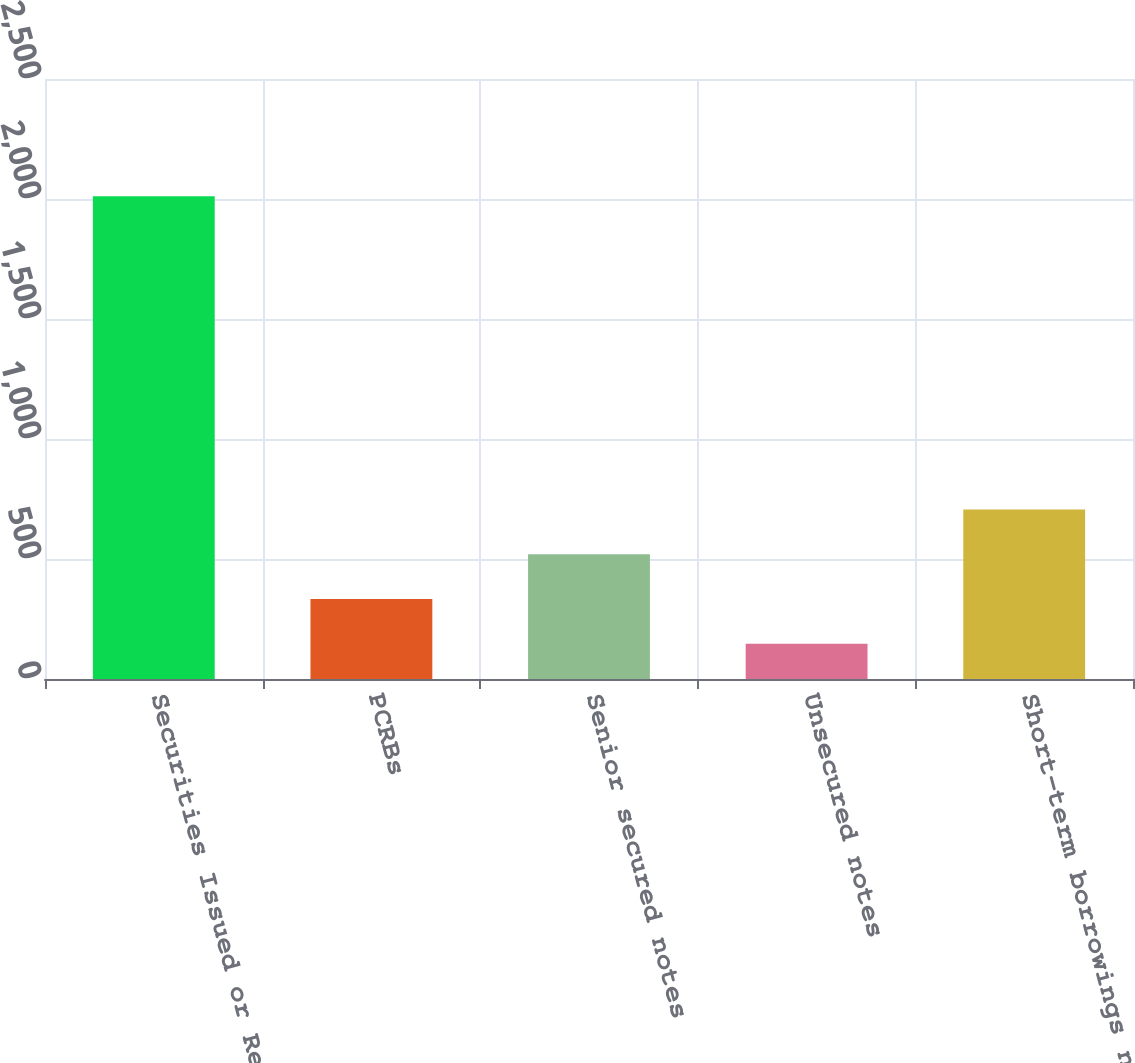<chart> <loc_0><loc_0><loc_500><loc_500><bar_chart><fcel>Securities Issued or Redeemed<fcel>PCRBs<fcel>Senior secured notes<fcel>Unsecured notes<fcel>Short-term borrowings net<nl><fcel>2011<fcel>333.4<fcel>519.8<fcel>147<fcel>706.2<nl></chart> 